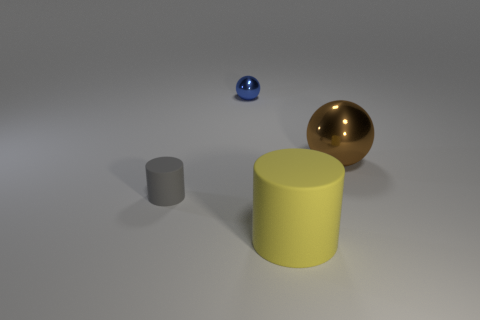Add 2 brown metal objects. How many objects exist? 6 Add 3 gray shiny balls. How many gray shiny balls exist? 3 Subtract 0 green cubes. How many objects are left? 4 Subtract all matte things. Subtract all red blocks. How many objects are left? 2 Add 3 blue metal spheres. How many blue metal spheres are left? 4 